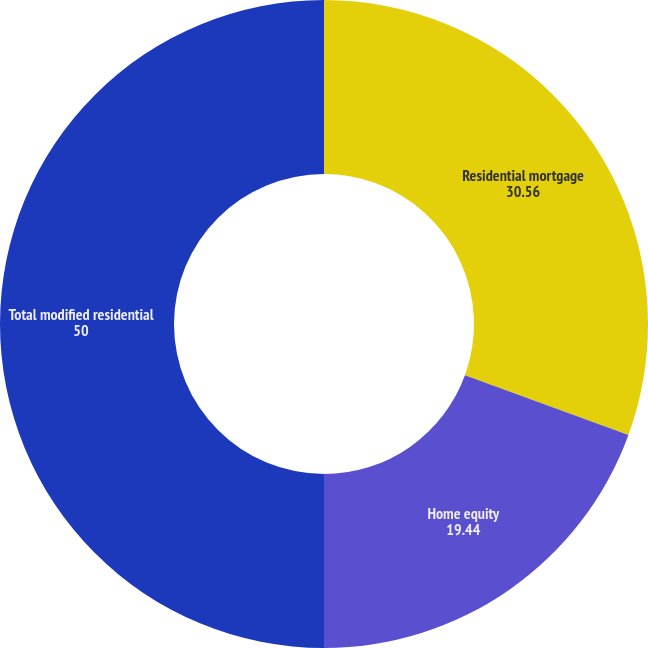Convert chart to OTSL. <chart><loc_0><loc_0><loc_500><loc_500><pie_chart><fcel>Residential mortgage<fcel>Home equity<fcel>Total modified residential<nl><fcel>30.56%<fcel>19.44%<fcel>50.0%<nl></chart> 